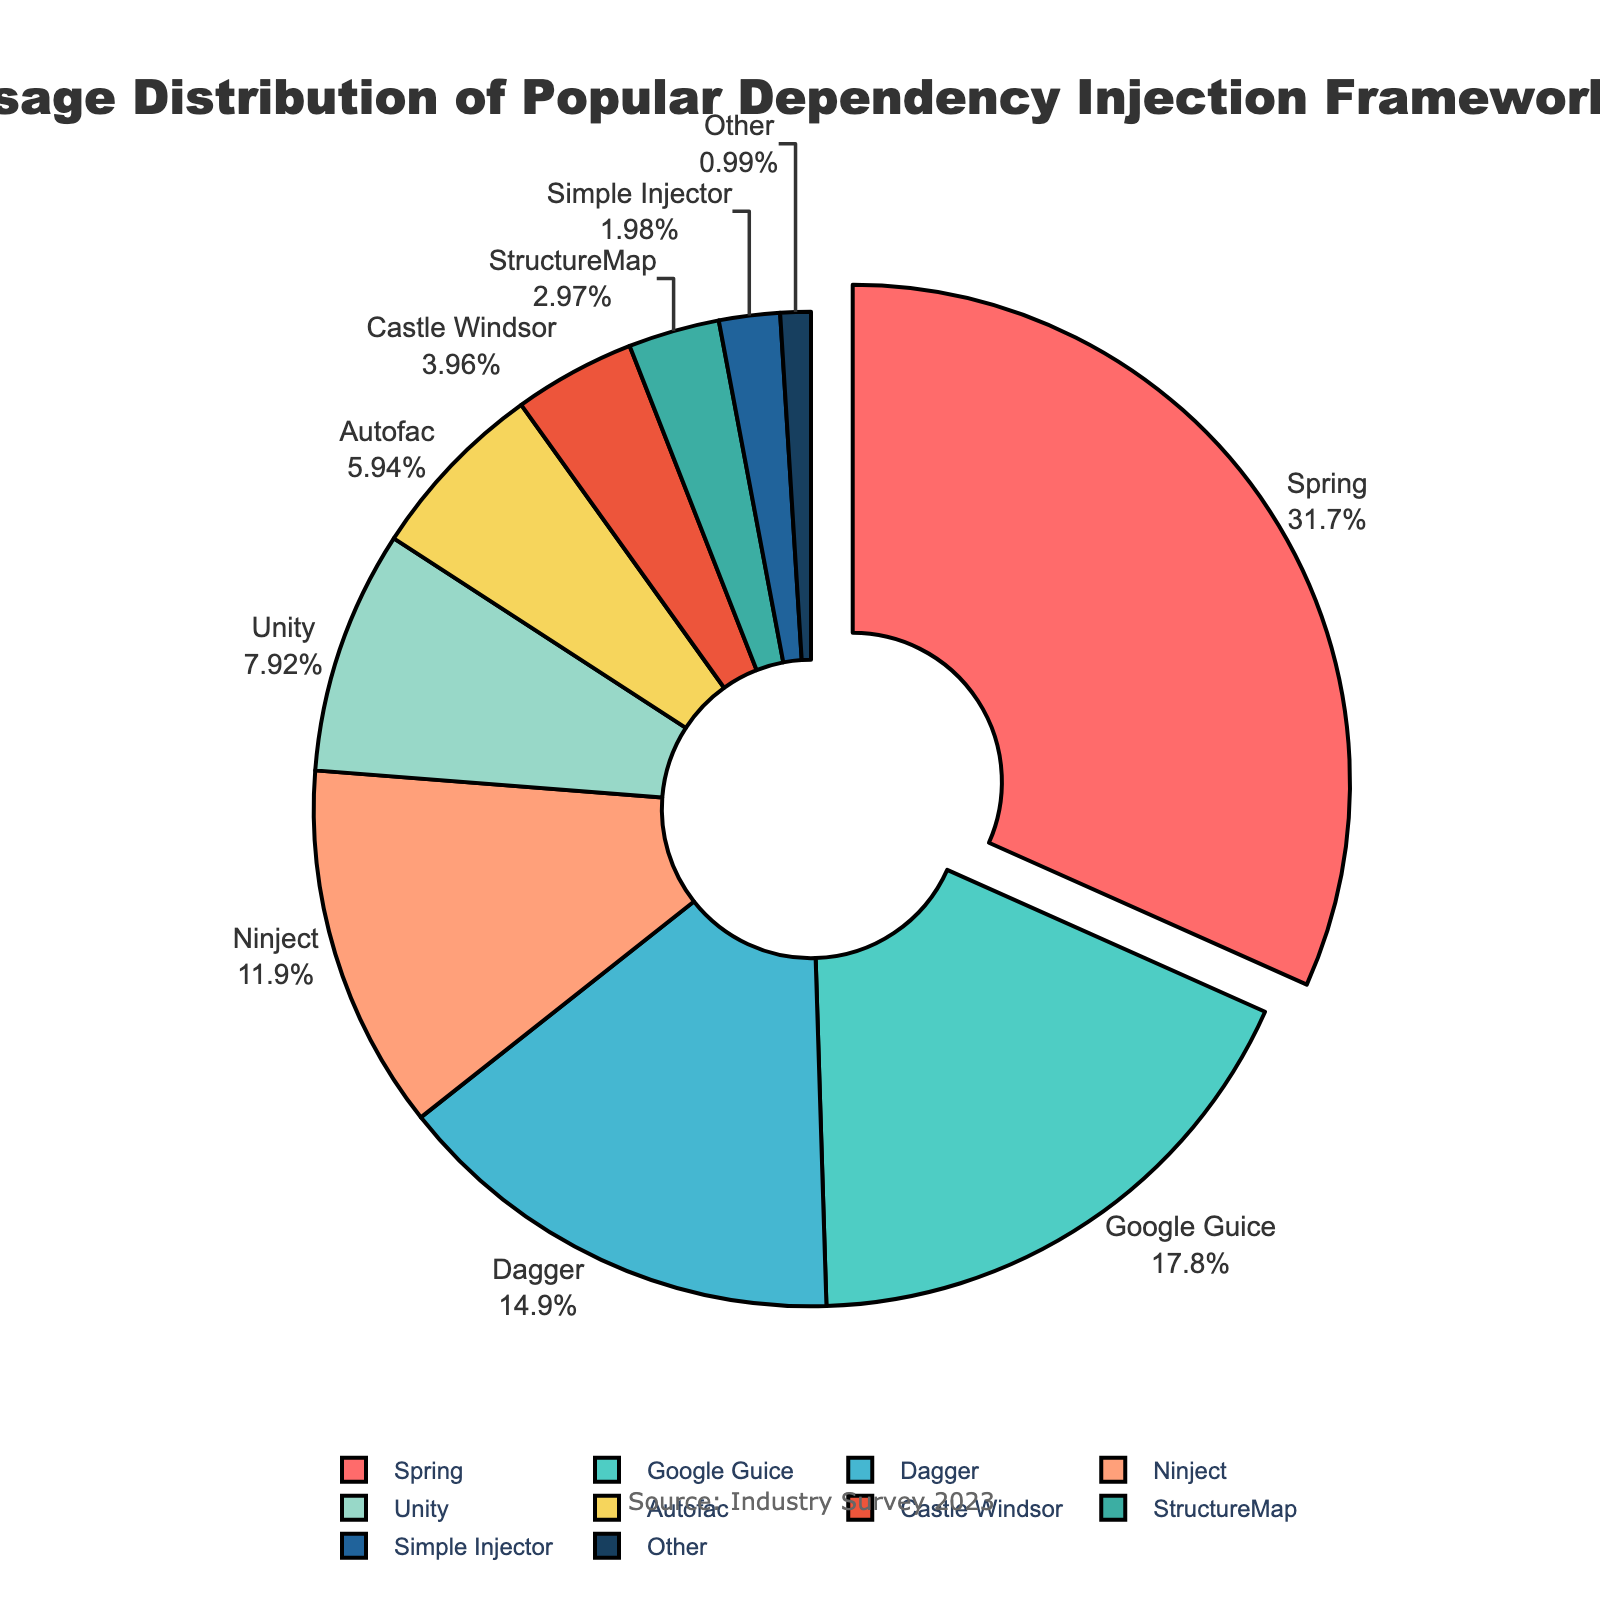Which framework has the highest usage percentage? The framework with the largest portion on the pie chart, in addition to being pulled slightly outward, is Spring with 32%.
Answer: Spring What is the combined usage percentage of Ninject and Unity? According to the pie chart, Ninject has 12% and Unity has 8%. Adding these together gives 12% + 8% = 20%.
Answer: 20% Which frameworks have a usage percentage of less than 5%? By examining the smaller slices of the pie chart visually, we can see that Castle Windsor, StructureMap, Simple Injector, and Other fall into this category.
Answer: Castle Windsor, StructureMap, Simple Injector, Other What is the difference in usage percentage between Google Guice and Dagger? The pie chart shows Google Guice at 18% and Dagger at 15%. The difference is 18% - 15% = 3%.
Answer: 3% Which frameworks are represented by shades of blue? Analyzing the color coding in the pie chart, the blue shades are used for Unity and StructureMap.
Answer: Unity, StructureMap What is the total usage percentage of all frameworks excluding the top three? The top three frameworks are Spring (32%), Google Guice (18%), and Dagger (15%). Summing these up gives 32% + 18% + 15% = 65%. Subtracting from 100% (total) results in 100% - 65% = 35%.
Answer: 35% How does the usage percentage of Autofac compare to that of Ninject? Ninject is 12% while Autofac is 6%. Ninject has a higher usage percentage compared to Autofac.
Answer: Ninject has a higher usage percentage What percentage of the frameworks have usage values that are below 10%? Observing the pie chart, there are six frameworks with percentages below 10%: Unity, Autofac, Castle Windsor, StructureMap, Simple Injector, and Other. There are ten frameworks in total, so 6 frameworks out of 10 equals 60%.
Answer: 60% If you combined the usage percentages of StructureMap and Simple Injector, how would their total compare to Unity? StructureMap has 3% and Simple Injector has 2%. Their combined percentage is 3% + 2% = 5%, which is less than Unity's 8%.
Answer: Less than Unity Which framework is assigned the green color? Looking at the color assignments in the pie chart, Google Guice is the framework represented by green.
Answer: Google Guice 